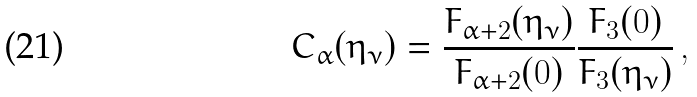Convert formula to latex. <formula><loc_0><loc_0><loc_500><loc_500>C _ { \alpha } ( \eta _ { \nu } ) = \frac { F _ { \alpha + 2 } ( \eta _ { \nu } ) } { F _ { \alpha + 2 } ( 0 ) } \frac { F _ { 3 } ( 0 ) } { F _ { 3 } ( \eta _ { \nu } ) } \, ,</formula> 